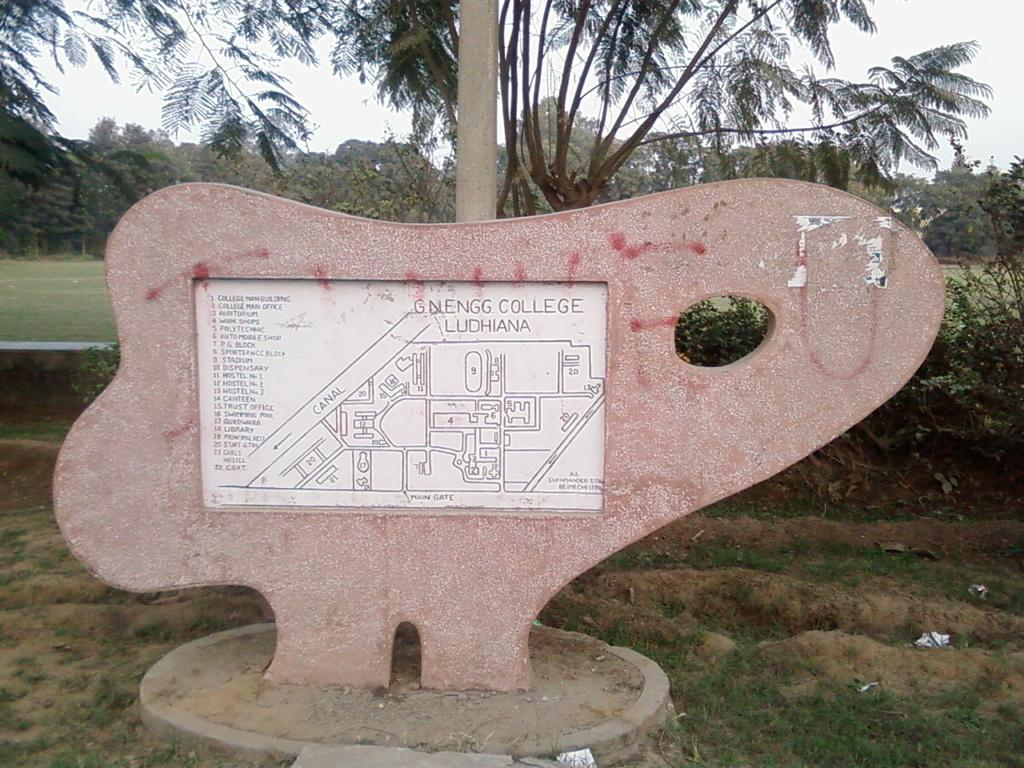What is depicted on the stone in the image? There is a route map on a stone in the image. What can be seen in the background of the image? There are trees and the sky visible in the background of the image. What type of vegetation is present at the bottom of the image? There is grass at the bottom of the image. What type of meat is being offered as a sacrifice in the image? There is no meat or sacrifice present in the image; it features a route map on a stone, trees, and the sky in the background, and grass at the bottom. 